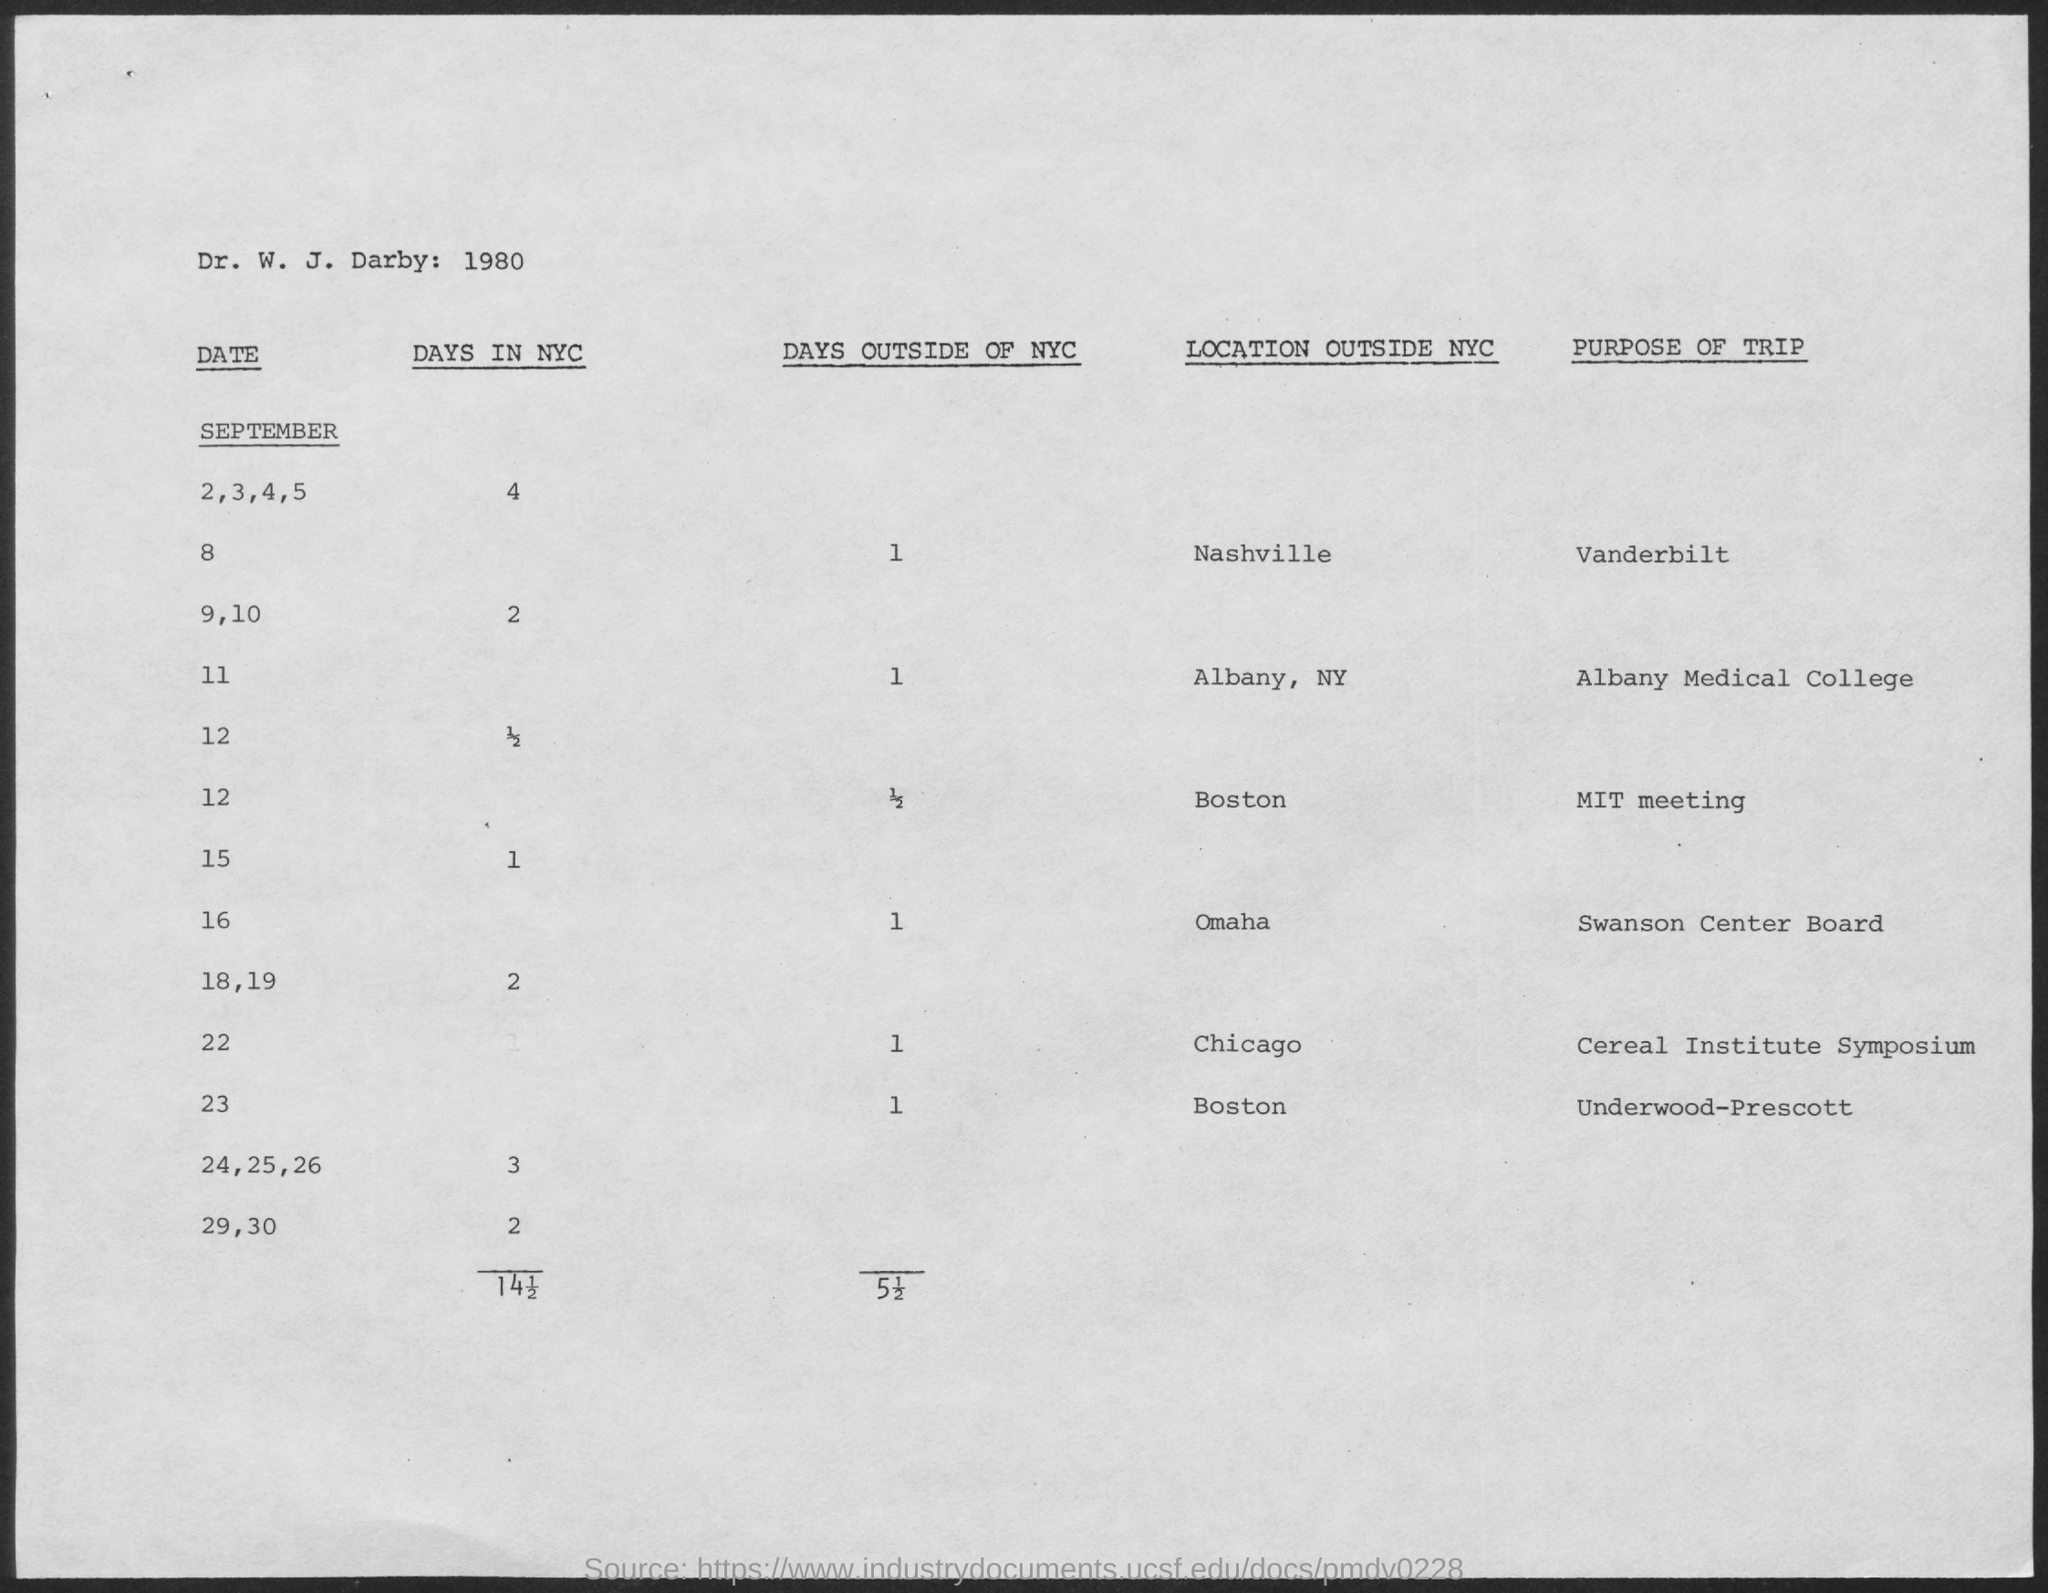Point out several critical features in this image. As of September 16th, there are a total of 30 days outside of New York City. There are two days in New York City for September 29 and 30. The number of days in NYC for September 18th and 19th is two. As of September 11th, there have been 1 day outside of New York City. There are 30 days in NYC for September 15, according to the declaration. 